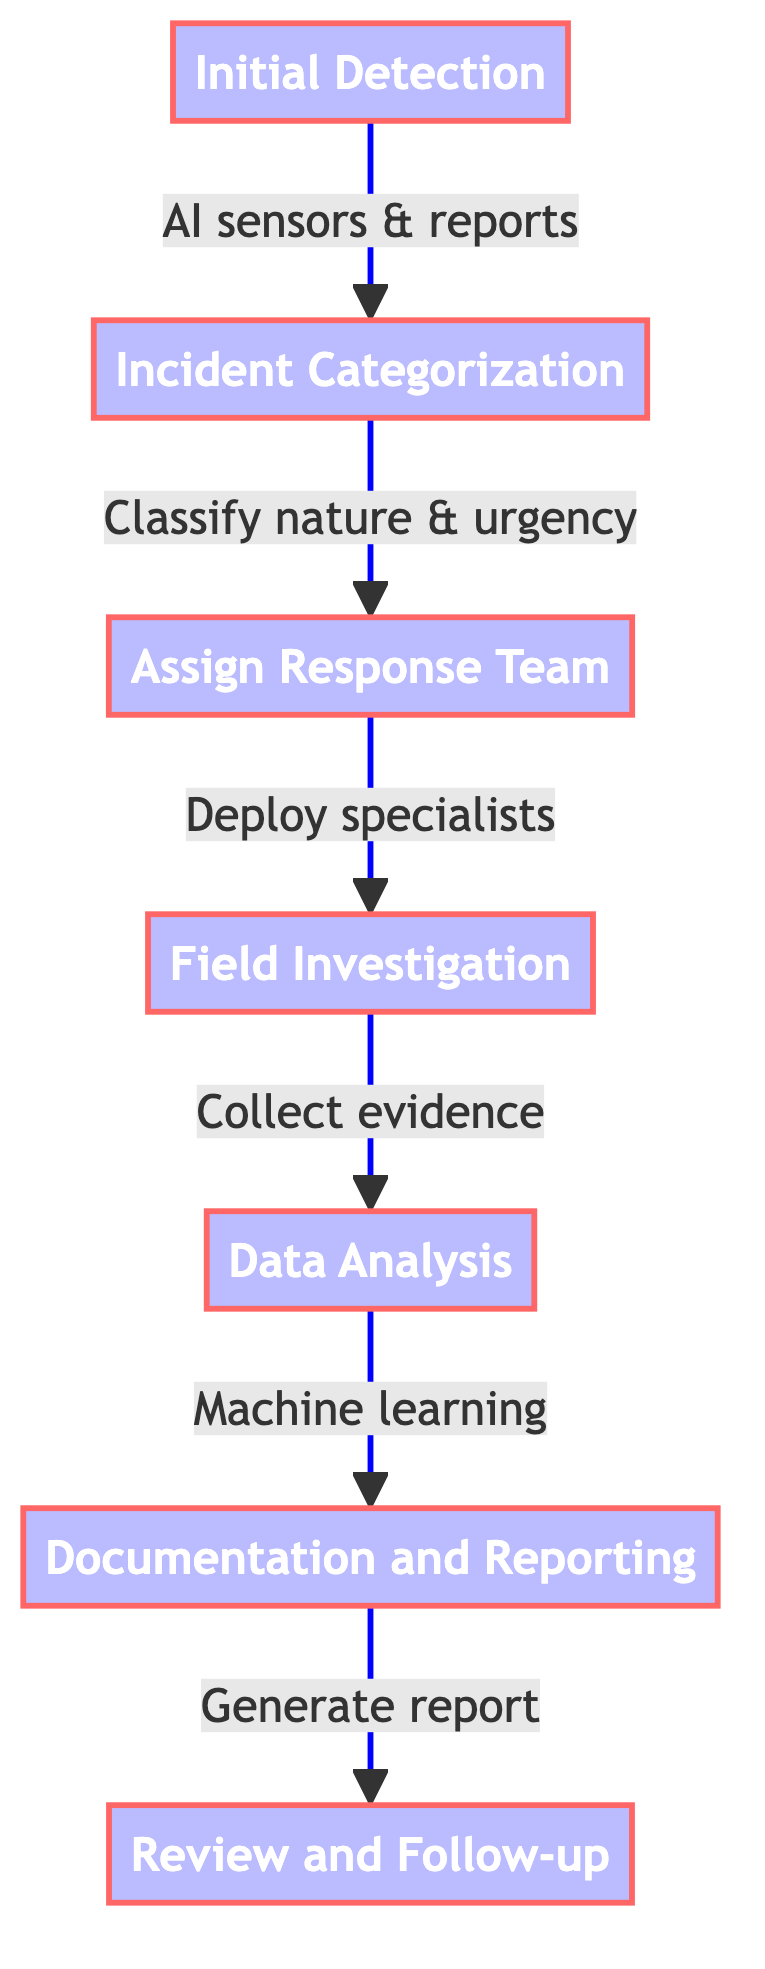What is the first step in the pathway? The first step in the pathway is identified as "Initial Detection" based on the sequence of steps outlined in the diagram.
Answer: Initial Detection How many main steps are in the pathway? By counting the distinct nodes listed in the pathway, there are seven main steps present.
Answer: 7 What follows after "Field Investigation"? Following "Field Investigation," the next step according to the flow is "Data Analysis," which indicates the process continues from there.
Answer: Data Analysis Which team is assigned after assessing the nature of the incident? After the assessment of the incident's nature and urgency in "Incident Categorization," the responsible team is assigned in the "Assign Response Team" step.
Answer: Assign Response Team What tools are mentioned for field investigations? The steps related to conducting field investigations mention the use of tools such as EMF detectors, infrared cameras, and EVP recorders, as part of the investigation process.
Answer: EMF detectors, infrared cameras, EVP recorders What is the last step in the pathway? The final step in the pathway is labeled as "Review and Follow-up" which indicates the concluding stage of the process described in the flow.
Answer: Review and Follow-up Which step involves machine learning? The step that incorporates machine learning is "Data Analysis," as it focuses on analyzing evidence with algorithms to validate occurrences.
Answer: Data Analysis What step comes directly after "Documentation and Reporting"? The step that comes directly after "Documentation and Reporting" is "Review and Follow-up," indicating the next action to be taken after documentation.
Answer: Review and Follow-up What is the purpose of "Initial Detection"? The purpose of "Initial Detection" is to utilize AI-driven sensors and public reports to identify potential supernatural occurrences at the outset of the pathway.
Answer: Identify potential supernatural occurrences 